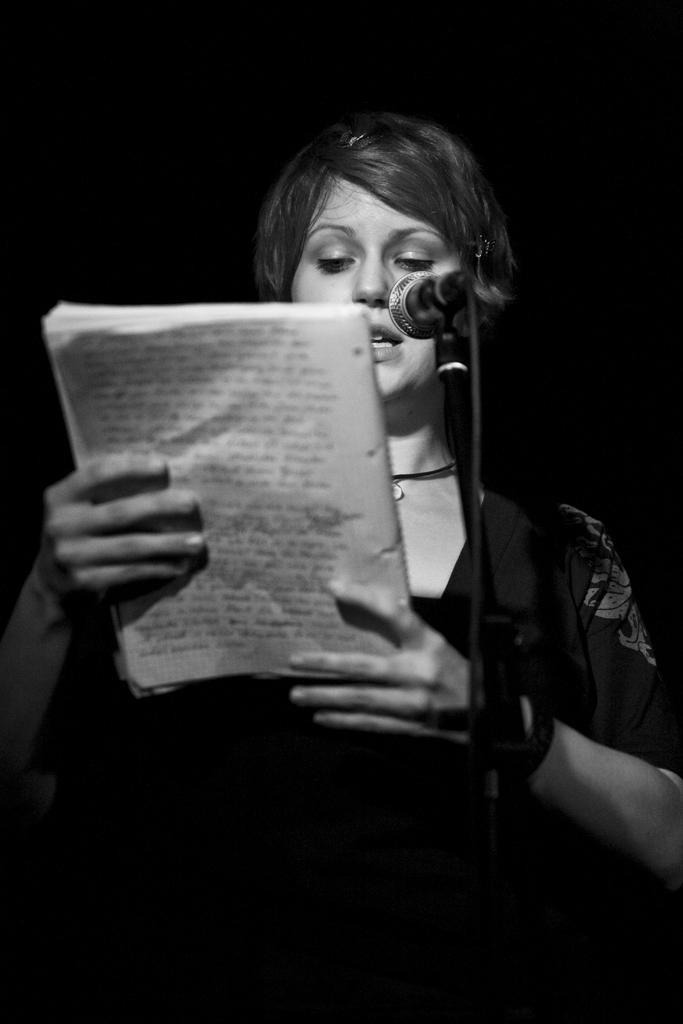In one or two sentences, can you explain what this image depicts? This is a black and white image and here we can see a lady holding a book and there is a mic. 